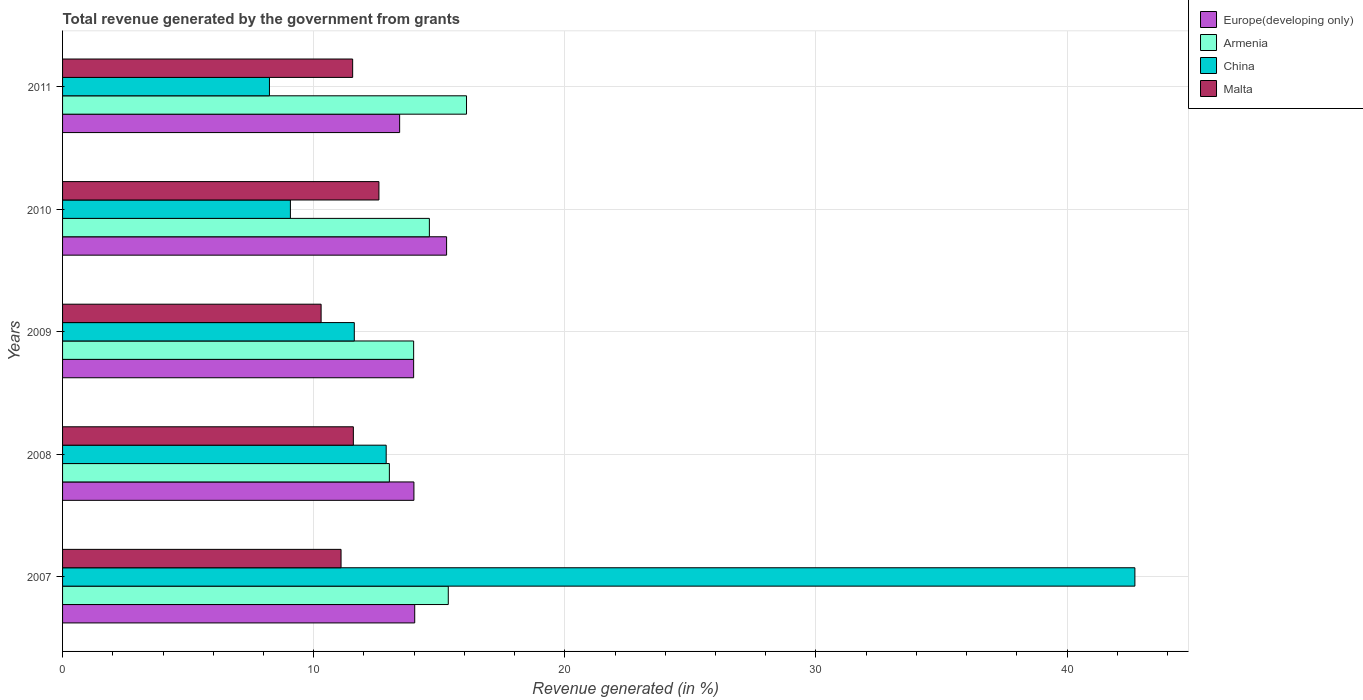How many different coloured bars are there?
Provide a succinct answer. 4. Are the number of bars per tick equal to the number of legend labels?
Make the answer very short. Yes. How many bars are there on the 2nd tick from the top?
Give a very brief answer. 4. What is the label of the 1st group of bars from the top?
Your answer should be compact. 2011. What is the total revenue generated in Europe(developing only) in 2007?
Offer a very short reply. 14.02. Across all years, what is the maximum total revenue generated in Europe(developing only)?
Provide a succinct answer. 15.29. Across all years, what is the minimum total revenue generated in Europe(developing only)?
Your response must be concise. 13.42. In which year was the total revenue generated in China minimum?
Your answer should be compact. 2011. What is the total total revenue generated in Armenia in the graph?
Keep it short and to the point. 73.05. What is the difference between the total revenue generated in Armenia in 2008 and that in 2010?
Offer a very short reply. -1.59. What is the difference between the total revenue generated in China in 2010 and the total revenue generated in Malta in 2011?
Give a very brief answer. -2.48. What is the average total revenue generated in Malta per year?
Make the answer very short. 11.42. In the year 2011, what is the difference between the total revenue generated in Armenia and total revenue generated in Europe(developing only)?
Your answer should be compact. 2.66. What is the ratio of the total revenue generated in Armenia in 2009 to that in 2011?
Offer a terse response. 0.87. Is the total revenue generated in China in 2010 less than that in 2011?
Ensure brevity in your answer.  No. Is the difference between the total revenue generated in Armenia in 2008 and 2011 greater than the difference between the total revenue generated in Europe(developing only) in 2008 and 2011?
Your response must be concise. No. What is the difference between the highest and the second highest total revenue generated in Europe(developing only)?
Your response must be concise. 1.27. What is the difference between the highest and the lowest total revenue generated in Europe(developing only)?
Provide a succinct answer. 1.87. In how many years, is the total revenue generated in Europe(developing only) greater than the average total revenue generated in Europe(developing only) taken over all years?
Your answer should be very brief. 1. Is the sum of the total revenue generated in China in 2007 and 2009 greater than the maximum total revenue generated in Malta across all years?
Give a very brief answer. Yes. Is it the case that in every year, the sum of the total revenue generated in China and total revenue generated in Malta is greater than the total revenue generated in Europe(developing only)?
Ensure brevity in your answer.  Yes. Are all the bars in the graph horizontal?
Make the answer very short. Yes. How many years are there in the graph?
Keep it short and to the point. 5. What is the difference between two consecutive major ticks on the X-axis?
Ensure brevity in your answer.  10. Are the values on the major ticks of X-axis written in scientific E-notation?
Provide a succinct answer. No. Does the graph contain any zero values?
Your answer should be very brief. No. Does the graph contain grids?
Keep it short and to the point. Yes. What is the title of the graph?
Your answer should be very brief. Total revenue generated by the government from grants. What is the label or title of the X-axis?
Offer a terse response. Revenue generated (in %). What is the Revenue generated (in %) of Europe(developing only) in 2007?
Your answer should be very brief. 14.02. What is the Revenue generated (in %) of Armenia in 2007?
Provide a succinct answer. 15.36. What is the Revenue generated (in %) of China in 2007?
Offer a terse response. 42.7. What is the Revenue generated (in %) in Malta in 2007?
Offer a very short reply. 11.09. What is the Revenue generated (in %) of Europe(developing only) in 2008?
Provide a succinct answer. 13.99. What is the Revenue generated (in %) in Armenia in 2008?
Offer a very short reply. 13.01. What is the Revenue generated (in %) of China in 2008?
Ensure brevity in your answer.  12.89. What is the Revenue generated (in %) of Malta in 2008?
Give a very brief answer. 11.58. What is the Revenue generated (in %) of Europe(developing only) in 2009?
Your answer should be very brief. 13.98. What is the Revenue generated (in %) of Armenia in 2009?
Your response must be concise. 13.98. What is the Revenue generated (in %) of China in 2009?
Ensure brevity in your answer.  11.62. What is the Revenue generated (in %) of Malta in 2009?
Give a very brief answer. 10.3. What is the Revenue generated (in %) in Europe(developing only) in 2010?
Your answer should be very brief. 15.29. What is the Revenue generated (in %) of Armenia in 2010?
Make the answer very short. 14.61. What is the Revenue generated (in %) in China in 2010?
Ensure brevity in your answer.  9.07. What is the Revenue generated (in %) of Malta in 2010?
Keep it short and to the point. 12.6. What is the Revenue generated (in %) in Europe(developing only) in 2011?
Ensure brevity in your answer.  13.42. What is the Revenue generated (in %) of Armenia in 2011?
Provide a short and direct response. 16.09. What is the Revenue generated (in %) in China in 2011?
Provide a succinct answer. 8.24. What is the Revenue generated (in %) of Malta in 2011?
Provide a succinct answer. 11.55. Across all years, what is the maximum Revenue generated (in %) in Europe(developing only)?
Make the answer very short. 15.29. Across all years, what is the maximum Revenue generated (in %) of Armenia?
Offer a very short reply. 16.09. Across all years, what is the maximum Revenue generated (in %) in China?
Offer a terse response. 42.7. Across all years, what is the maximum Revenue generated (in %) in Malta?
Provide a short and direct response. 12.6. Across all years, what is the minimum Revenue generated (in %) in Europe(developing only)?
Provide a short and direct response. 13.42. Across all years, what is the minimum Revenue generated (in %) of Armenia?
Offer a very short reply. 13.01. Across all years, what is the minimum Revenue generated (in %) of China?
Provide a short and direct response. 8.24. Across all years, what is the minimum Revenue generated (in %) of Malta?
Ensure brevity in your answer.  10.3. What is the total Revenue generated (in %) of Europe(developing only) in the graph?
Your answer should be very brief. 70.71. What is the total Revenue generated (in %) of Armenia in the graph?
Your response must be concise. 73.05. What is the total Revenue generated (in %) of China in the graph?
Keep it short and to the point. 84.52. What is the total Revenue generated (in %) in Malta in the graph?
Give a very brief answer. 57.12. What is the difference between the Revenue generated (in %) in Europe(developing only) in 2007 and that in 2008?
Offer a terse response. 0.03. What is the difference between the Revenue generated (in %) in Armenia in 2007 and that in 2008?
Offer a very short reply. 2.35. What is the difference between the Revenue generated (in %) in China in 2007 and that in 2008?
Your response must be concise. 29.82. What is the difference between the Revenue generated (in %) of Malta in 2007 and that in 2008?
Ensure brevity in your answer.  -0.49. What is the difference between the Revenue generated (in %) of Europe(developing only) in 2007 and that in 2009?
Your answer should be compact. 0.04. What is the difference between the Revenue generated (in %) in Armenia in 2007 and that in 2009?
Your response must be concise. 1.38. What is the difference between the Revenue generated (in %) in China in 2007 and that in 2009?
Provide a succinct answer. 31.09. What is the difference between the Revenue generated (in %) of Malta in 2007 and that in 2009?
Give a very brief answer. 0.79. What is the difference between the Revenue generated (in %) in Europe(developing only) in 2007 and that in 2010?
Ensure brevity in your answer.  -1.27. What is the difference between the Revenue generated (in %) in Armenia in 2007 and that in 2010?
Offer a terse response. 0.75. What is the difference between the Revenue generated (in %) of China in 2007 and that in 2010?
Make the answer very short. 33.63. What is the difference between the Revenue generated (in %) in Malta in 2007 and that in 2010?
Provide a short and direct response. -1.51. What is the difference between the Revenue generated (in %) of Europe(developing only) in 2007 and that in 2011?
Your response must be concise. 0.6. What is the difference between the Revenue generated (in %) in Armenia in 2007 and that in 2011?
Your answer should be very brief. -0.73. What is the difference between the Revenue generated (in %) of China in 2007 and that in 2011?
Your answer should be very brief. 34.46. What is the difference between the Revenue generated (in %) of Malta in 2007 and that in 2011?
Make the answer very short. -0.46. What is the difference between the Revenue generated (in %) in Europe(developing only) in 2008 and that in 2009?
Make the answer very short. 0.01. What is the difference between the Revenue generated (in %) in Armenia in 2008 and that in 2009?
Offer a terse response. -0.97. What is the difference between the Revenue generated (in %) of China in 2008 and that in 2009?
Keep it short and to the point. 1.27. What is the difference between the Revenue generated (in %) in Malta in 2008 and that in 2009?
Your response must be concise. 1.28. What is the difference between the Revenue generated (in %) of Europe(developing only) in 2008 and that in 2010?
Ensure brevity in your answer.  -1.3. What is the difference between the Revenue generated (in %) in Armenia in 2008 and that in 2010?
Ensure brevity in your answer.  -1.59. What is the difference between the Revenue generated (in %) of China in 2008 and that in 2010?
Your answer should be compact. 3.81. What is the difference between the Revenue generated (in %) of Malta in 2008 and that in 2010?
Ensure brevity in your answer.  -1.02. What is the difference between the Revenue generated (in %) of Europe(developing only) in 2008 and that in 2011?
Keep it short and to the point. 0.57. What is the difference between the Revenue generated (in %) of Armenia in 2008 and that in 2011?
Provide a short and direct response. -3.07. What is the difference between the Revenue generated (in %) in China in 2008 and that in 2011?
Provide a succinct answer. 4.65. What is the difference between the Revenue generated (in %) of Malta in 2008 and that in 2011?
Provide a succinct answer. 0.03. What is the difference between the Revenue generated (in %) of Europe(developing only) in 2009 and that in 2010?
Offer a very short reply. -1.31. What is the difference between the Revenue generated (in %) of Armenia in 2009 and that in 2010?
Your response must be concise. -0.63. What is the difference between the Revenue generated (in %) in China in 2009 and that in 2010?
Provide a short and direct response. 2.54. What is the difference between the Revenue generated (in %) in Malta in 2009 and that in 2010?
Offer a very short reply. -2.3. What is the difference between the Revenue generated (in %) in Europe(developing only) in 2009 and that in 2011?
Provide a short and direct response. 0.56. What is the difference between the Revenue generated (in %) in Armenia in 2009 and that in 2011?
Offer a terse response. -2.11. What is the difference between the Revenue generated (in %) of China in 2009 and that in 2011?
Provide a short and direct response. 3.38. What is the difference between the Revenue generated (in %) of Malta in 2009 and that in 2011?
Provide a short and direct response. -1.26. What is the difference between the Revenue generated (in %) in Europe(developing only) in 2010 and that in 2011?
Your answer should be compact. 1.87. What is the difference between the Revenue generated (in %) of Armenia in 2010 and that in 2011?
Provide a short and direct response. -1.48. What is the difference between the Revenue generated (in %) of China in 2010 and that in 2011?
Keep it short and to the point. 0.83. What is the difference between the Revenue generated (in %) of Malta in 2010 and that in 2011?
Your answer should be very brief. 1.05. What is the difference between the Revenue generated (in %) in Europe(developing only) in 2007 and the Revenue generated (in %) in Armenia in 2008?
Provide a succinct answer. 1.01. What is the difference between the Revenue generated (in %) of Europe(developing only) in 2007 and the Revenue generated (in %) of China in 2008?
Keep it short and to the point. 1.14. What is the difference between the Revenue generated (in %) of Europe(developing only) in 2007 and the Revenue generated (in %) of Malta in 2008?
Ensure brevity in your answer.  2.44. What is the difference between the Revenue generated (in %) of Armenia in 2007 and the Revenue generated (in %) of China in 2008?
Offer a very short reply. 2.47. What is the difference between the Revenue generated (in %) of Armenia in 2007 and the Revenue generated (in %) of Malta in 2008?
Provide a succinct answer. 3.78. What is the difference between the Revenue generated (in %) of China in 2007 and the Revenue generated (in %) of Malta in 2008?
Provide a short and direct response. 31.12. What is the difference between the Revenue generated (in %) of Europe(developing only) in 2007 and the Revenue generated (in %) of Armenia in 2009?
Offer a terse response. 0.04. What is the difference between the Revenue generated (in %) in Europe(developing only) in 2007 and the Revenue generated (in %) in China in 2009?
Your answer should be very brief. 2.41. What is the difference between the Revenue generated (in %) of Europe(developing only) in 2007 and the Revenue generated (in %) of Malta in 2009?
Offer a very short reply. 3.73. What is the difference between the Revenue generated (in %) of Armenia in 2007 and the Revenue generated (in %) of China in 2009?
Provide a short and direct response. 3.74. What is the difference between the Revenue generated (in %) of Armenia in 2007 and the Revenue generated (in %) of Malta in 2009?
Your answer should be very brief. 5.06. What is the difference between the Revenue generated (in %) of China in 2007 and the Revenue generated (in %) of Malta in 2009?
Offer a very short reply. 32.41. What is the difference between the Revenue generated (in %) in Europe(developing only) in 2007 and the Revenue generated (in %) in Armenia in 2010?
Your response must be concise. -0.58. What is the difference between the Revenue generated (in %) in Europe(developing only) in 2007 and the Revenue generated (in %) in China in 2010?
Offer a terse response. 4.95. What is the difference between the Revenue generated (in %) of Europe(developing only) in 2007 and the Revenue generated (in %) of Malta in 2010?
Ensure brevity in your answer.  1.43. What is the difference between the Revenue generated (in %) of Armenia in 2007 and the Revenue generated (in %) of China in 2010?
Your response must be concise. 6.29. What is the difference between the Revenue generated (in %) in Armenia in 2007 and the Revenue generated (in %) in Malta in 2010?
Your answer should be compact. 2.76. What is the difference between the Revenue generated (in %) of China in 2007 and the Revenue generated (in %) of Malta in 2010?
Make the answer very short. 30.1. What is the difference between the Revenue generated (in %) in Europe(developing only) in 2007 and the Revenue generated (in %) in Armenia in 2011?
Keep it short and to the point. -2.06. What is the difference between the Revenue generated (in %) in Europe(developing only) in 2007 and the Revenue generated (in %) in China in 2011?
Provide a succinct answer. 5.78. What is the difference between the Revenue generated (in %) of Europe(developing only) in 2007 and the Revenue generated (in %) of Malta in 2011?
Offer a terse response. 2.47. What is the difference between the Revenue generated (in %) of Armenia in 2007 and the Revenue generated (in %) of China in 2011?
Provide a short and direct response. 7.12. What is the difference between the Revenue generated (in %) in Armenia in 2007 and the Revenue generated (in %) in Malta in 2011?
Provide a succinct answer. 3.81. What is the difference between the Revenue generated (in %) in China in 2007 and the Revenue generated (in %) in Malta in 2011?
Your answer should be very brief. 31.15. What is the difference between the Revenue generated (in %) in Europe(developing only) in 2008 and the Revenue generated (in %) in Armenia in 2009?
Keep it short and to the point. 0.01. What is the difference between the Revenue generated (in %) of Europe(developing only) in 2008 and the Revenue generated (in %) of China in 2009?
Offer a very short reply. 2.37. What is the difference between the Revenue generated (in %) of Europe(developing only) in 2008 and the Revenue generated (in %) of Malta in 2009?
Provide a short and direct response. 3.7. What is the difference between the Revenue generated (in %) of Armenia in 2008 and the Revenue generated (in %) of China in 2009?
Provide a short and direct response. 1.4. What is the difference between the Revenue generated (in %) of Armenia in 2008 and the Revenue generated (in %) of Malta in 2009?
Offer a very short reply. 2.72. What is the difference between the Revenue generated (in %) in China in 2008 and the Revenue generated (in %) in Malta in 2009?
Make the answer very short. 2.59. What is the difference between the Revenue generated (in %) of Europe(developing only) in 2008 and the Revenue generated (in %) of Armenia in 2010?
Your answer should be very brief. -0.62. What is the difference between the Revenue generated (in %) in Europe(developing only) in 2008 and the Revenue generated (in %) in China in 2010?
Ensure brevity in your answer.  4.92. What is the difference between the Revenue generated (in %) of Europe(developing only) in 2008 and the Revenue generated (in %) of Malta in 2010?
Provide a short and direct response. 1.39. What is the difference between the Revenue generated (in %) of Armenia in 2008 and the Revenue generated (in %) of China in 2010?
Provide a succinct answer. 3.94. What is the difference between the Revenue generated (in %) of Armenia in 2008 and the Revenue generated (in %) of Malta in 2010?
Your response must be concise. 0.42. What is the difference between the Revenue generated (in %) of China in 2008 and the Revenue generated (in %) of Malta in 2010?
Ensure brevity in your answer.  0.29. What is the difference between the Revenue generated (in %) of Europe(developing only) in 2008 and the Revenue generated (in %) of Armenia in 2011?
Keep it short and to the point. -2.09. What is the difference between the Revenue generated (in %) of Europe(developing only) in 2008 and the Revenue generated (in %) of China in 2011?
Your answer should be very brief. 5.75. What is the difference between the Revenue generated (in %) of Europe(developing only) in 2008 and the Revenue generated (in %) of Malta in 2011?
Ensure brevity in your answer.  2.44. What is the difference between the Revenue generated (in %) of Armenia in 2008 and the Revenue generated (in %) of China in 2011?
Provide a short and direct response. 4.78. What is the difference between the Revenue generated (in %) of Armenia in 2008 and the Revenue generated (in %) of Malta in 2011?
Make the answer very short. 1.46. What is the difference between the Revenue generated (in %) in China in 2008 and the Revenue generated (in %) in Malta in 2011?
Your answer should be compact. 1.34. What is the difference between the Revenue generated (in %) in Europe(developing only) in 2009 and the Revenue generated (in %) in Armenia in 2010?
Your answer should be compact. -0.63. What is the difference between the Revenue generated (in %) of Europe(developing only) in 2009 and the Revenue generated (in %) of China in 2010?
Your response must be concise. 4.91. What is the difference between the Revenue generated (in %) in Europe(developing only) in 2009 and the Revenue generated (in %) in Malta in 2010?
Ensure brevity in your answer.  1.38. What is the difference between the Revenue generated (in %) of Armenia in 2009 and the Revenue generated (in %) of China in 2010?
Provide a succinct answer. 4.91. What is the difference between the Revenue generated (in %) of Armenia in 2009 and the Revenue generated (in %) of Malta in 2010?
Offer a terse response. 1.38. What is the difference between the Revenue generated (in %) in China in 2009 and the Revenue generated (in %) in Malta in 2010?
Offer a terse response. -0.98. What is the difference between the Revenue generated (in %) in Europe(developing only) in 2009 and the Revenue generated (in %) in Armenia in 2011?
Provide a short and direct response. -2.11. What is the difference between the Revenue generated (in %) in Europe(developing only) in 2009 and the Revenue generated (in %) in China in 2011?
Offer a terse response. 5.74. What is the difference between the Revenue generated (in %) of Europe(developing only) in 2009 and the Revenue generated (in %) of Malta in 2011?
Offer a very short reply. 2.43. What is the difference between the Revenue generated (in %) in Armenia in 2009 and the Revenue generated (in %) in China in 2011?
Make the answer very short. 5.74. What is the difference between the Revenue generated (in %) in Armenia in 2009 and the Revenue generated (in %) in Malta in 2011?
Provide a short and direct response. 2.43. What is the difference between the Revenue generated (in %) in China in 2009 and the Revenue generated (in %) in Malta in 2011?
Ensure brevity in your answer.  0.07. What is the difference between the Revenue generated (in %) in Europe(developing only) in 2010 and the Revenue generated (in %) in Armenia in 2011?
Offer a terse response. -0.79. What is the difference between the Revenue generated (in %) in Europe(developing only) in 2010 and the Revenue generated (in %) in China in 2011?
Keep it short and to the point. 7.05. What is the difference between the Revenue generated (in %) of Europe(developing only) in 2010 and the Revenue generated (in %) of Malta in 2011?
Offer a terse response. 3.74. What is the difference between the Revenue generated (in %) in Armenia in 2010 and the Revenue generated (in %) in China in 2011?
Your response must be concise. 6.37. What is the difference between the Revenue generated (in %) in Armenia in 2010 and the Revenue generated (in %) in Malta in 2011?
Provide a succinct answer. 3.06. What is the difference between the Revenue generated (in %) of China in 2010 and the Revenue generated (in %) of Malta in 2011?
Provide a short and direct response. -2.48. What is the average Revenue generated (in %) in Europe(developing only) per year?
Provide a short and direct response. 14.14. What is the average Revenue generated (in %) in Armenia per year?
Offer a terse response. 14.61. What is the average Revenue generated (in %) of China per year?
Your answer should be very brief. 16.9. What is the average Revenue generated (in %) in Malta per year?
Make the answer very short. 11.42. In the year 2007, what is the difference between the Revenue generated (in %) in Europe(developing only) and Revenue generated (in %) in Armenia?
Keep it short and to the point. -1.34. In the year 2007, what is the difference between the Revenue generated (in %) of Europe(developing only) and Revenue generated (in %) of China?
Your response must be concise. -28.68. In the year 2007, what is the difference between the Revenue generated (in %) of Europe(developing only) and Revenue generated (in %) of Malta?
Make the answer very short. 2.93. In the year 2007, what is the difference between the Revenue generated (in %) of Armenia and Revenue generated (in %) of China?
Offer a very short reply. -27.34. In the year 2007, what is the difference between the Revenue generated (in %) of Armenia and Revenue generated (in %) of Malta?
Make the answer very short. 4.27. In the year 2007, what is the difference between the Revenue generated (in %) in China and Revenue generated (in %) in Malta?
Offer a terse response. 31.61. In the year 2008, what is the difference between the Revenue generated (in %) in Europe(developing only) and Revenue generated (in %) in Armenia?
Offer a very short reply. 0.98. In the year 2008, what is the difference between the Revenue generated (in %) of Europe(developing only) and Revenue generated (in %) of China?
Offer a terse response. 1.1. In the year 2008, what is the difference between the Revenue generated (in %) of Europe(developing only) and Revenue generated (in %) of Malta?
Provide a short and direct response. 2.41. In the year 2008, what is the difference between the Revenue generated (in %) in Armenia and Revenue generated (in %) in China?
Give a very brief answer. 0.13. In the year 2008, what is the difference between the Revenue generated (in %) of Armenia and Revenue generated (in %) of Malta?
Your answer should be compact. 1.43. In the year 2008, what is the difference between the Revenue generated (in %) in China and Revenue generated (in %) in Malta?
Make the answer very short. 1.31. In the year 2009, what is the difference between the Revenue generated (in %) of Europe(developing only) and Revenue generated (in %) of China?
Give a very brief answer. 2.36. In the year 2009, what is the difference between the Revenue generated (in %) of Europe(developing only) and Revenue generated (in %) of Malta?
Offer a very short reply. 3.69. In the year 2009, what is the difference between the Revenue generated (in %) in Armenia and Revenue generated (in %) in China?
Your response must be concise. 2.36. In the year 2009, what is the difference between the Revenue generated (in %) in Armenia and Revenue generated (in %) in Malta?
Offer a terse response. 3.69. In the year 2009, what is the difference between the Revenue generated (in %) in China and Revenue generated (in %) in Malta?
Provide a short and direct response. 1.32. In the year 2010, what is the difference between the Revenue generated (in %) of Europe(developing only) and Revenue generated (in %) of Armenia?
Keep it short and to the point. 0.69. In the year 2010, what is the difference between the Revenue generated (in %) of Europe(developing only) and Revenue generated (in %) of China?
Your response must be concise. 6.22. In the year 2010, what is the difference between the Revenue generated (in %) in Europe(developing only) and Revenue generated (in %) in Malta?
Your response must be concise. 2.69. In the year 2010, what is the difference between the Revenue generated (in %) in Armenia and Revenue generated (in %) in China?
Keep it short and to the point. 5.53. In the year 2010, what is the difference between the Revenue generated (in %) of Armenia and Revenue generated (in %) of Malta?
Your response must be concise. 2.01. In the year 2010, what is the difference between the Revenue generated (in %) in China and Revenue generated (in %) in Malta?
Offer a terse response. -3.53. In the year 2011, what is the difference between the Revenue generated (in %) in Europe(developing only) and Revenue generated (in %) in Armenia?
Ensure brevity in your answer.  -2.66. In the year 2011, what is the difference between the Revenue generated (in %) of Europe(developing only) and Revenue generated (in %) of China?
Offer a terse response. 5.18. In the year 2011, what is the difference between the Revenue generated (in %) of Europe(developing only) and Revenue generated (in %) of Malta?
Make the answer very short. 1.87. In the year 2011, what is the difference between the Revenue generated (in %) in Armenia and Revenue generated (in %) in China?
Make the answer very short. 7.85. In the year 2011, what is the difference between the Revenue generated (in %) of Armenia and Revenue generated (in %) of Malta?
Give a very brief answer. 4.53. In the year 2011, what is the difference between the Revenue generated (in %) in China and Revenue generated (in %) in Malta?
Offer a terse response. -3.31. What is the ratio of the Revenue generated (in %) in Europe(developing only) in 2007 to that in 2008?
Provide a succinct answer. 1. What is the ratio of the Revenue generated (in %) in Armenia in 2007 to that in 2008?
Make the answer very short. 1.18. What is the ratio of the Revenue generated (in %) of China in 2007 to that in 2008?
Offer a terse response. 3.31. What is the ratio of the Revenue generated (in %) in Malta in 2007 to that in 2008?
Give a very brief answer. 0.96. What is the ratio of the Revenue generated (in %) in Europe(developing only) in 2007 to that in 2009?
Offer a terse response. 1. What is the ratio of the Revenue generated (in %) in Armenia in 2007 to that in 2009?
Your answer should be very brief. 1.1. What is the ratio of the Revenue generated (in %) in China in 2007 to that in 2009?
Give a very brief answer. 3.68. What is the ratio of the Revenue generated (in %) in Malta in 2007 to that in 2009?
Provide a short and direct response. 1.08. What is the ratio of the Revenue generated (in %) of Europe(developing only) in 2007 to that in 2010?
Your answer should be very brief. 0.92. What is the ratio of the Revenue generated (in %) in Armenia in 2007 to that in 2010?
Provide a short and direct response. 1.05. What is the ratio of the Revenue generated (in %) in China in 2007 to that in 2010?
Give a very brief answer. 4.71. What is the ratio of the Revenue generated (in %) of Malta in 2007 to that in 2010?
Your answer should be very brief. 0.88. What is the ratio of the Revenue generated (in %) in Europe(developing only) in 2007 to that in 2011?
Provide a short and direct response. 1.04. What is the ratio of the Revenue generated (in %) of Armenia in 2007 to that in 2011?
Your response must be concise. 0.95. What is the ratio of the Revenue generated (in %) of China in 2007 to that in 2011?
Your response must be concise. 5.18. What is the ratio of the Revenue generated (in %) in Malta in 2007 to that in 2011?
Ensure brevity in your answer.  0.96. What is the ratio of the Revenue generated (in %) of Europe(developing only) in 2008 to that in 2009?
Your answer should be very brief. 1. What is the ratio of the Revenue generated (in %) in Armenia in 2008 to that in 2009?
Provide a succinct answer. 0.93. What is the ratio of the Revenue generated (in %) in China in 2008 to that in 2009?
Provide a short and direct response. 1.11. What is the ratio of the Revenue generated (in %) in Malta in 2008 to that in 2009?
Provide a short and direct response. 1.12. What is the ratio of the Revenue generated (in %) of Europe(developing only) in 2008 to that in 2010?
Provide a succinct answer. 0.91. What is the ratio of the Revenue generated (in %) in Armenia in 2008 to that in 2010?
Make the answer very short. 0.89. What is the ratio of the Revenue generated (in %) of China in 2008 to that in 2010?
Your answer should be compact. 1.42. What is the ratio of the Revenue generated (in %) in Malta in 2008 to that in 2010?
Your response must be concise. 0.92. What is the ratio of the Revenue generated (in %) in Europe(developing only) in 2008 to that in 2011?
Offer a terse response. 1.04. What is the ratio of the Revenue generated (in %) of Armenia in 2008 to that in 2011?
Provide a succinct answer. 0.81. What is the ratio of the Revenue generated (in %) of China in 2008 to that in 2011?
Make the answer very short. 1.56. What is the ratio of the Revenue generated (in %) of Malta in 2008 to that in 2011?
Provide a short and direct response. 1. What is the ratio of the Revenue generated (in %) of Europe(developing only) in 2009 to that in 2010?
Provide a short and direct response. 0.91. What is the ratio of the Revenue generated (in %) of Armenia in 2009 to that in 2010?
Ensure brevity in your answer.  0.96. What is the ratio of the Revenue generated (in %) of China in 2009 to that in 2010?
Provide a short and direct response. 1.28. What is the ratio of the Revenue generated (in %) in Malta in 2009 to that in 2010?
Offer a terse response. 0.82. What is the ratio of the Revenue generated (in %) in Europe(developing only) in 2009 to that in 2011?
Your answer should be very brief. 1.04. What is the ratio of the Revenue generated (in %) in Armenia in 2009 to that in 2011?
Your answer should be very brief. 0.87. What is the ratio of the Revenue generated (in %) in China in 2009 to that in 2011?
Give a very brief answer. 1.41. What is the ratio of the Revenue generated (in %) in Malta in 2009 to that in 2011?
Provide a succinct answer. 0.89. What is the ratio of the Revenue generated (in %) of Europe(developing only) in 2010 to that in 2011?
Give a very brief answer. 1.14. What is the ratio of the Revenue generated (in %) in Armenia in 2010 to that in 2011?
Keep it short and to the point. 0.91. What is the ratio of the Revenue generated (in %) in China in 2010 to that in 2011?
Ensure brevity in your answer.  1.1. What is the ratio of the Revenue generated (in %) in Malta in 2010 to that in 2011?
Give a very brief answer. 1.09. What is the difference between the highest and the second highest Revenue generated (in %) of Europe(developing only)?
Your answer should be compact. 1.27. What is the difference between the highest and the second highest Revenue generated (in %) of Armenia?
Ensure brevity in your answer.  0.73. What is the difference between the highest and the second highest Revenue generated (in %) of China?
Your answer should be very brief. 29.82. What is the difference between the highest and the second highest Revenue generated (in %) in Malta?
Ensure brevity in your answer.  1.02. What is the difference between the highest and the lowest Revenue generated (in %) of Europe(developing only)?
Your response must be concise. 1.87. What is the difference between the highest and the lowest Revenue generated (in %) of Armenia?
Make the answer very short. 3.07. What is the difference between the highest and the lowest Revenue generated (in %) of China?
Make the answer very short. 34.46. What is the difference between the highest and the lowest Revenue generated (in %) in Malta?
Make the answer very short. 2.3. 